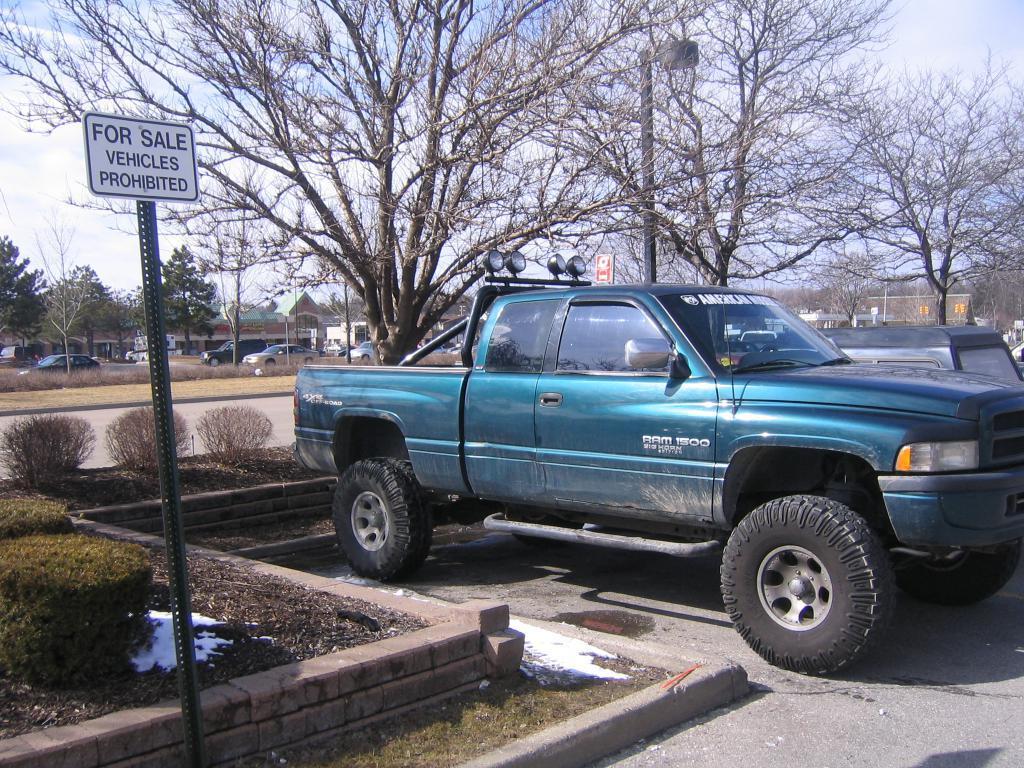In one or two sentences, can you explain what this image depicts? In this image I see number of cars and I see the path and I see number of plants and I see something is written on this board. In the background I see number of trees and houses and I see the clear sky and I see few poles. 